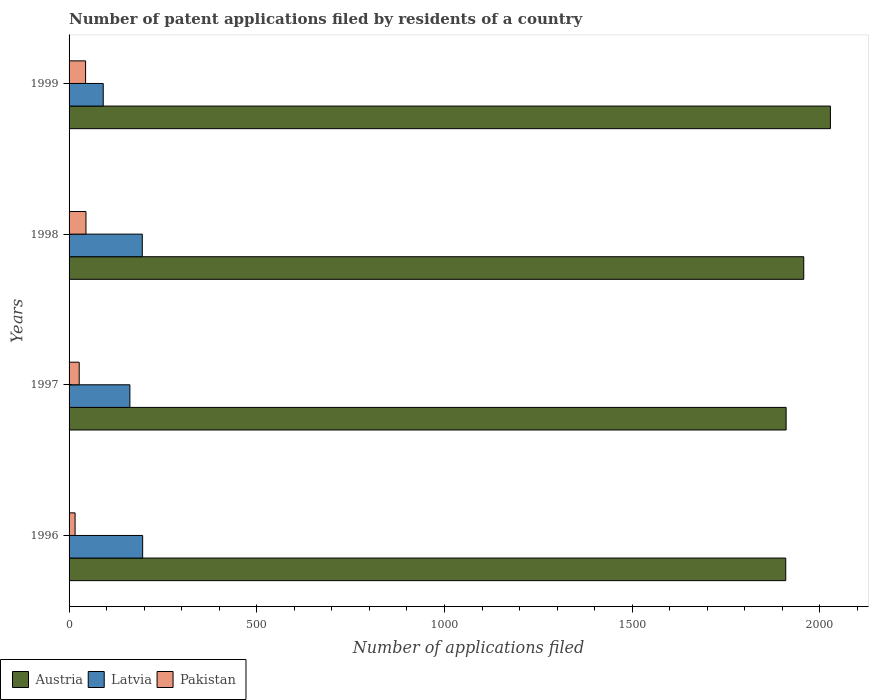How many different coloured bars are there?
Your response must be concise. 3. How many groups of bars are there?
Make the answer very short. 4. Are the number of bars per tick equal to the number of legend labels?
Provide a short and direct response. Yes. Are the number of bars on each tick of the Y-axis equal?
Offer a terse response. Yes. How many bars are there on the 1st tick from the top?
Your response must be concise. 3. How many bars are there on the 1st tick from the bottom?
Offer a terse response. 3. What is the label of the 1st group of bars from the top?
Offer a terse response. 1999. In how many cases, is the number of bars for a given year not equal to the number of legend labels?
Make the answer very short. 0. What is the number of applications filed in Latvia in 1997?
Your answer should be very brief. 162. Across all years, what is the maximum number of applications filed in Austria?
Your answer should be very brief. 2028. Across all years, what is the minimum number of applications filed in Latvia?
Make the answer very short. 91. In which year was the number of applications filed in Austria minimum?
Your response must be concise. 1996. What is the total number of applications filed in Pakistan in the graph?
Give a very brief answer. 132. What is the difference between the number of applications filed in Pakistan in 1996 and that in 1997?
Your response must be concise. -11. What is the difference between the number of applications filed in Austria in 1998 and the number of applications filed in Pakistan in 1999?
Provide a succinct answer. 1913. What is the average number of applications filed in Austria per year?
Offer a very short reply. 1951. In the year 1999, what is the difference between the number of applications filed in Pakistan and number of applications filed in Austria?
Give a very brief answer. -1984. What is the ratio of the number of applications filed in Pakistan in 1996 to that in 1999?
Provide a short and direct response. 0.36. What is the difference between the highest and the second highest number of applications filed in Latvia?
Provide a short and direct response. 1. What is the difference between the highest and the lowest number of applications filed in Austria?
Give a very brief answer. 119. Is the sum of the number of applications filed in Austria in 1997 and 1999 greater than the maximum number of applications filed in Latvia across all years?
Your response must be concise. Yes. What does the 1st bar from the top in 1996 represents?
Your response must be concise. Pakistan. What does the 2nd bar from the bottom in 1999 represents?
Your answer should be compact. Latvia. Is it the case that in every year, the sum of the number of applications filed in Latvia and number of applications filed in Pakistan is greater than the number of applications filed in Austria?
Offer a very short reply. No. Are all the bars in the graph horizontal?
Make the answer very short. Yes. How many years are there in the graph?
Your response must be concise. 4. What is the difference between two consecutive major ticks on the X-axis?
Keep it short and to the point. 500. Are the values on the major ticks of X-axis written in scientific E-notation?
Keep it short and to the point. No. Does the graph contain grids?
Ensure brevity in your answer.  No. Where does the legend appear in the graph?
Ensure brevity in your answer.  Bottom left. How are the legend labels stacked?
Keep it short and to the point. Horizontal. What is the title of the graph?
Your answer should be very brief. Number of patent applications filed by residents of a country. Does "Slovak Republic" appear as one of the legend labels in the graph?
Offer a very short reply. No. What is the label or title of the X-axis?
Your answer should be compact. Number of applications filed. What is the Number of applications filed of Austria in 1996?
Make the answer very short. 1909. What is the Number of applications filed of Latvia in 1996?
Ensure brevity in your answer.  196. What is the Number of applications filed of Austria in 1997?
Ensure brevity in your answer.  1910. What is the Number of applications filed in Latvia in 1997?
Provide a succinct answer. 162. What is the Number of applications filed in Pakistan in 1997?
Your answer should be compact. 27. What is the Number of applications filed in Austria in 1998?
Your answer should be very brief. 1957. What is the Number of applications filed in Latvia in 1998?
Your answer should be compact. 195. What is the Number of applications filed of Pakistan in 1998?
Offer a very short reply. 45. What is the Number of applications filed of Austria in 1999?
Provide a succinct answer. 2028. What is the Number of applications filed in Latvia in 1999?
Your answer should be very brief. 91. What is the Number of applications filed in Pakistan in 1999?
Make the answer very short. 44. Across all years, what is the maximum Number of applications filed in Austria?
Keep it short and to the point. 2028. Across all years, what is the maximum Number of applications filed of Latvia?
Your response must be concise. 196. Across all years, what is the maximum Number of applications filed of Pakistan?
Keep it short and to the point. 45. Across all years, what is the minimum Number of applications filed of Austria?
Provide a short and direct response. 1909. Across all years, what is the minimum Number of applications filed in Latvia?
Ensure brevity in your answer.  91. Across all years, what is the minimum Number of applications filed in Pakistan?
Provide a short and direct response. 16. What is the total Number of applications filed in Austria in the graph?
Your response must be concise. 7804. What is the total Number of applications filed of Latvia in the graph?
Offer a very short reply. 644. What is the total Number of applications filed in Pakistan in the graph?
Your answer should be very brief. 132. What is the difference between the Number of applications filed of Austria in 1996 and that in 1997?
Your response must be concise. -1. What is the difference between the Number of applications filed in Pakistan in 1996 and that in 1997?
Offer a very short reply. -11. What is the difference between the Number of applications filed of Austria in 1996 and that in 1998?
Make the answer very short. -48. What is the difference between the Number of applications filed of Latvia in 1996 and that in 1998?
Your answer should be very brief. 1. What is the difference between the Number of applications filed of Austria in 1996 and that in 1999?
Your response must be concise. -119. What is the difference between the Number of applications filed of Latvia in 1996 and that in 1999?
Your answer should be very brief. 105. What is the difference between the Number of applications filed in Austria in 1997 and that in 1998?
Your response must be concise. -47. What is the difference between the Number of applications filed of Latvia in 1997 and that in 1998?
Ensure brevity in your answer.  -33. What is the difference between the Number of applications filed in Austria in 1997 and that in 1999?
Your answer should be very brief. -118. What is the difference between the Number of applications filed of Austria in 1998 and that in 1999?
Offer a terse response. -71. What is the difference between the Number of applications filed in Latvia in 1998 and that in 1999?
Your response must be concise. 104. What is the difference between the Number of applications filed in Pakistan in 1998 and that in 1999?
Offer a terse response. 1. What is the difference between the Number of applications filed of Austria in 1996 and the Number of applications filed of Latvia in 1997?
Give a very brief answer. 1747. What is the difference between the Number of applications filed of Austria in 1996 and the Number of applications filed of Pakistan in 1997?
Make the answer very short. 1882. What is the difference between the Number of applications filed of Latvia in 1996 and the Number of applications filed of Pakistan in 1997?
Offer a very short reply. 169. What is the difference between the Number of applications filed of Austria in 1996 and the Number of applications filed of Latvia in 1998?
Offer a terse response. 1714. What is the difference between the Number of applications filed of Austria in 1996 and the Number of applications filed of Pakistan in 1998?
Give a very brief answer. 1864. What is the difference between the Number of applications filed of Latvia in 1996 and the Number of applications filed of Pakistan in 1998?
Ensure brevity in your answer.  151. What is the difference between the Number of applications filed in Austria in 1996 and the Number of applications filed in Latvia in 1999?
Keep it short and to the point. 1818. What is the difference between the Number of applications filed of Austria in 1996 and the Number of applications filed of Pakistan in 1999?
Provide a short and direct response. 1865. What is the difference between the Number of applications filed in Latvia in 1996 and the Number of applications filed in Pakistan in 1999?
Give a very brief answer. 152. What is the difference between the Number of applications filed in Austria in 1997 and the Number of applications filed in Latvia in 1998?
Keep it short and to the point. 1715. What is the difference between the Number of applications filed of Austria in 1997 and the Number of applications filed of Pakistan in 1998?
Your response must be concise. 1865. What is the difference between the Number of applications filed of Latvia in 1997 and the Number of applications filed of Pakistan in 1998?
Give a very brief answer. 117. What is the difference between the Number of applications filed of Austria in 1997 and the Number of applications filed of Latvia in 1999?
Your answer should be compact. 1819. What is the difference between the Number of applications filed of Austria in 1997 and the Number of applications filed of Pakistan in 1999?
Your answer should be compact. 1866. What is the difference between the Number of applications filed in Latvia in 1997 and the Number of applications filed in Pakistan in 1999?
Make the answer very short. 118. What is the difference between the Number of applications filed of Austria in 1998 and the Number of applications filed of Latvia in 1999?
Make the answer very short. 1866. What is the difference between the Number of applications filed of Austria in 1998 and the Number of applications filed of Pakistan in 1999?
Provide a succinct answer. 1913. What is the difference between the Number of applications filed of Latvia in 1998 and the Number of applications filed of Pakistan in 1999?
Provide a short and direct response. 151. What is the average Number of applications filed in Austria per year?
Offer a terse response. 1951. What is the average Number of applications filed of Latvia per year?
Ensure brevity in your answer.  161. In the year 1996, what is the difference between the Number of applications filed of Austria and Number of applications filed of Latvia?
Your answer should be compact. 1713. In the year 1996, what is the difference between the Number of applications filed in Austria and Number of applications filed in Pakistan?
Offer a very short reply. 1893. In the year 1996, what is the difference between the Number of applications filed in Latvia and Number of applications filed in Pakistan?
Provide a short and direct response. 180. In the year 1997, what is the difference between the Number of applications filed in Austria and Number of applications filed in Latvia?
Your response must be concise. 1748. In the year 1997, what is the difference between the Number of applications filed in Austria and Number of applications filed in Pakistan?
Keep it short and to the point. 1883. In the year 1997, what is the difference between the Number of applications filed in Latvia and Number of applications filed in Pakistan?
Your response must be concise. 135. In the year 1998, what is the difference between the Number of applications filed in Austria and Number of applications filed in Latvia?
Your answer should be very brief. 1762. In the year 1998, what is the difference between the Number of applications filed in Austria and Number of applications filed in Pakistan?
Keep it short and to the point. 1912. In the year 1998, what is the difference between the Number of applications filed of Latvia and Number of applications filed of Pakistan?
Your answer should be very brief. 150. In the year 1999, what is the difference between the Number of applications filed of Austria and Number of applications filed of Latvia?
Ensure brevity in your answer.  1937. In the year 1999, what is the difference between the Number of applications filed in Austria and Number of applications filed in Pakistan?
Make the answer very short. 1984. What is the ratio of the Number of applications filed in Austria in 1996 to that in 1997?
Ensure brevity in your answer.  1. What is the ratio of the Number of applications filed in Latvia in 1996 to that in 1997?
Provide a succinct answer. 1.21. What is the ratio of the Number of applications filed of Pakistan in 1996 to that in 1997?
Ensure brevity in your answer.  0.59. What is the ratio of the Number of applications filed in Austria in 1996 to that in 1998?
Give a very brief answer. 0.98. What is the ratio of the Number of applications filed of Latvia in 1996 to that in 1998?
Your answer should be compact. 1.01. What is the ratio of the Number of applications filed in Pakistan in 1996 to that in 1998?
Offer a terse response. 0.36. What is the ratio of the Number of applications filed of Austria in 1996 to that in 1999?
Your answer should be compact. 0.94. What is the ratio of the Number of applications filed in Latvia in 1996 to that in 1999?
Provide a short and direct response. 2.15. What is the ratio of the Number of applications filed of Pakistan in 1996 to that in 1999?
Your answer should be compact. 0.36. What is the ratio of the Number of applications filed in Austria in 1997 to that in 1998?
Offer a terse response. 0.98. What is the ratio of the Number of applications filed in Latvia in 1997 to that in 1998?
Make the answer very short. 0.83. What is the ratio of the Number of applications filed in Austria in 1997 to that in 1999?
Your response must be concise. 0.94. What is the ratio of the Number of applications filed of Latvia in 1997 to that in 1999?
Your answer should be compact. 1.78. What is the ratio of the Number of applications filed in Pakistan in 1997 to that in 1999?
Provide a succinct answer. 0.61. What is the ratio of the Number of applications filed in Austria in 1998 to that in 1999?
Ensure brevity in your answer.  0.96. What is the ratio of the Number of applications filed of Latvia in 1998 to that in 1999?
Ensure brevity in your answer.  2.14. What is the ratio of the Number of applications filed in Pakistan in 1998 to that in 1999?
Provide a succinct answer. 1.02. What is the difference between the highest and the second highest Number of applications filed in Austria?
Provide a short and direct response. 71. What is the difference between the highest and the lowest Number of applications filed in Austria?
Make the answer very short. 119. What is the difference between the highest and the lowest Number of applications filed of Latvia?
Your answer should be compact. 105. What is the difference between the highest and the lowest Number of applications filed of Pakistan?
Your answer should be compact. 29. 